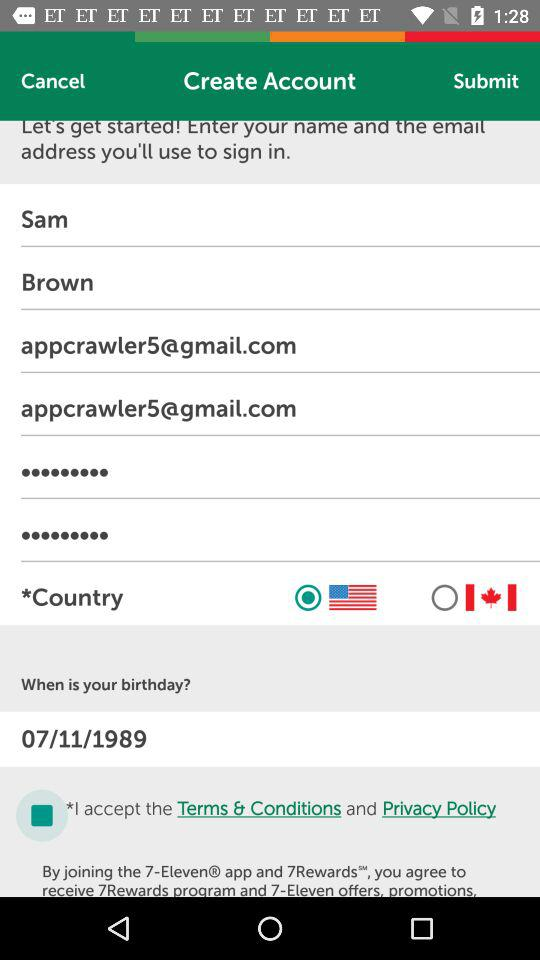What is the name of the person? The name is Sam Brown. 